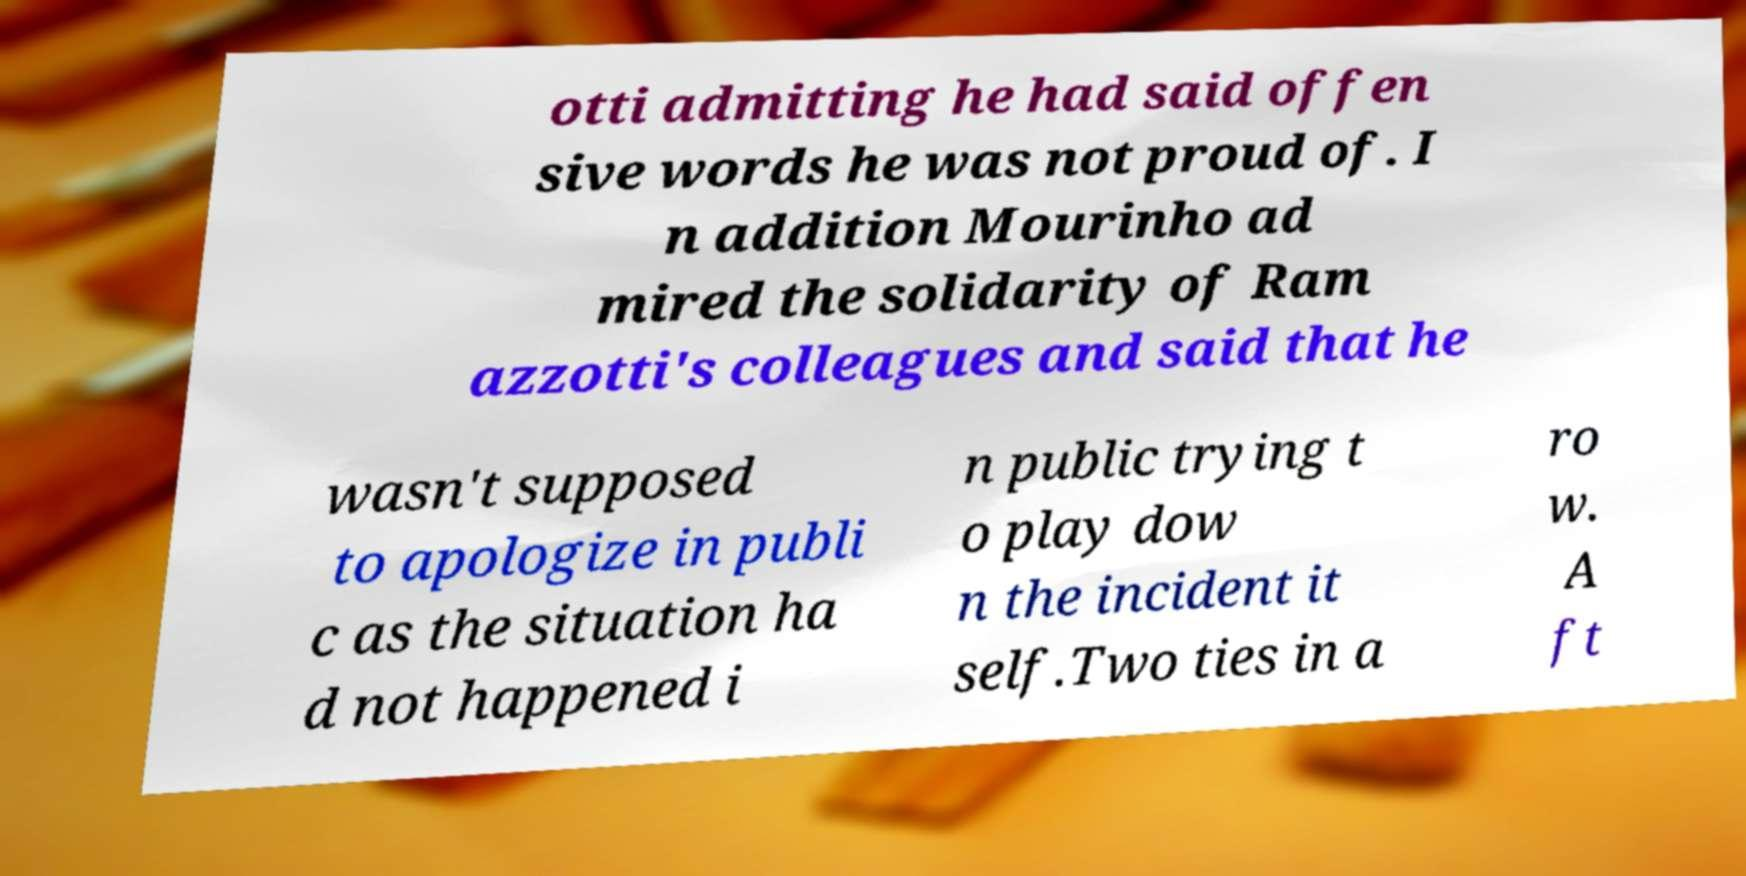Please read and relay the text visible in this image. What does it say? otti admitting he had said offen sive words he was not proud of. I n addition Mourinho ad mired the solidarity of Ram azzotti's colleagues and said that he wasn't supposed to apologize in publi c as the situation ha d not happened i n public trying t o play dow n the incident it self.Two ties in a ro w. A ft 